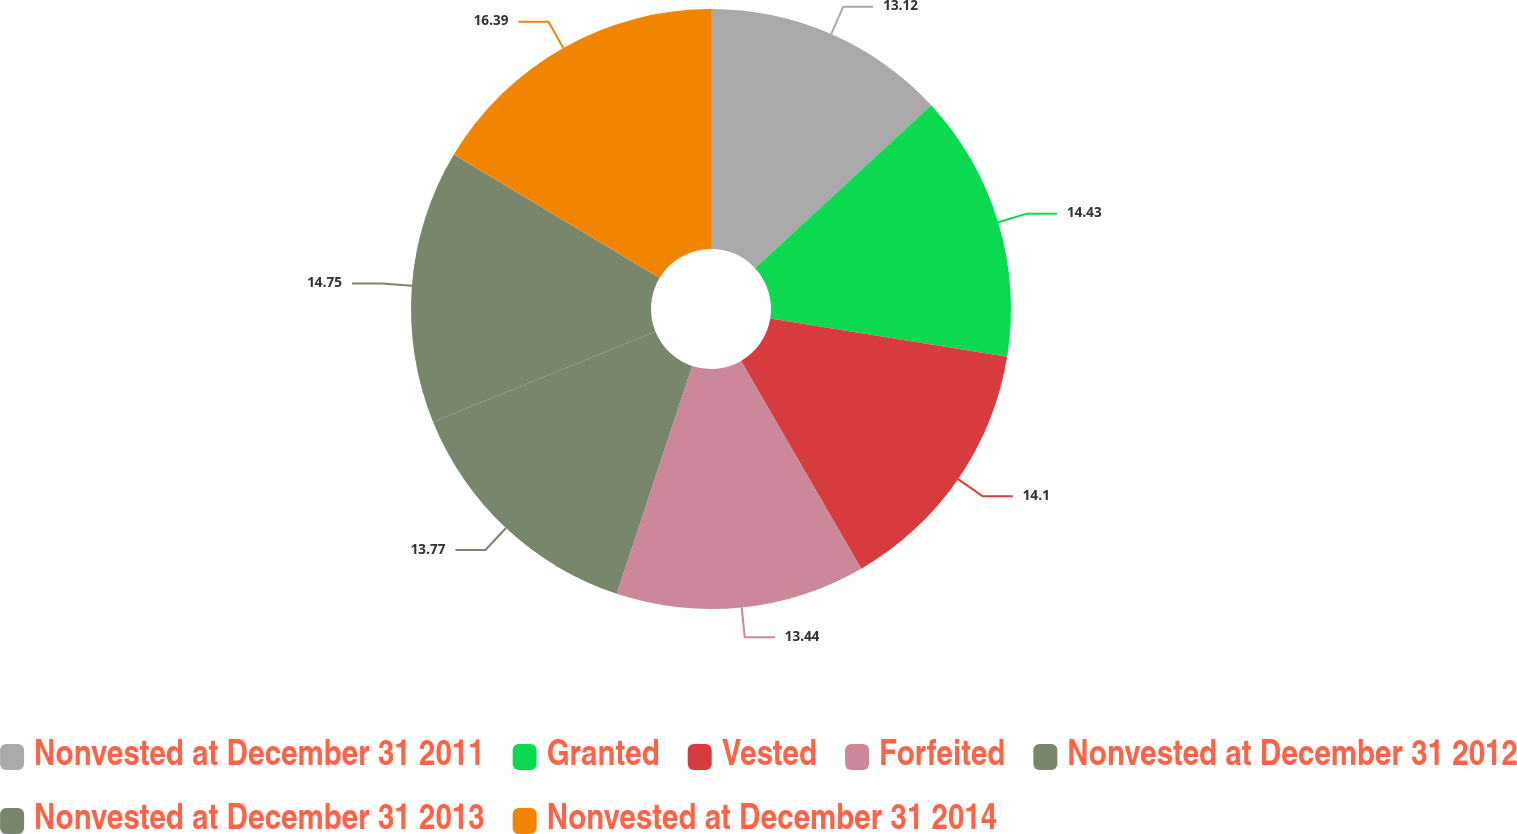Convert chart to OTSL. <chart><loc_0><loc_0><loc_500><loc_500><pie_chart><fcel>Nonvested at December 31 2011<fcel>Granted<fcel>Vested<fcel>Forfeited<fcel>Nonvested at December 31 2012<fcel>Nonvested at December 31 2013<fcel>Nonvested at December 31 2014<nl><fcel>13.12%<fcel>14.43%<fcel>14.1%<fcel>13.44%<fcel>13.77%<fcel>14.75%<fcel>16.39%<nl></chart> 